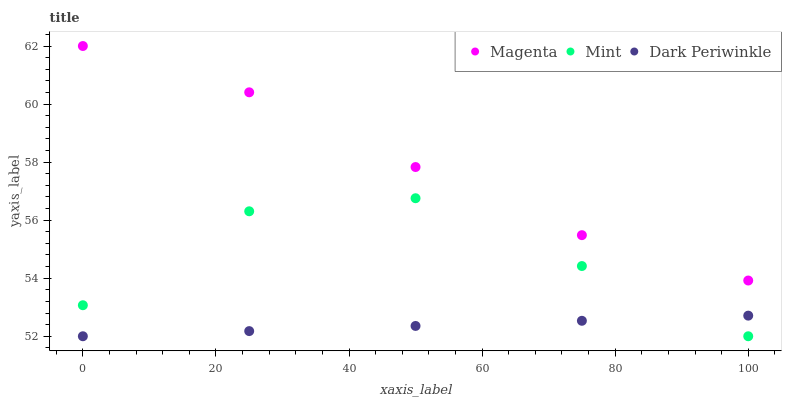Does Dark Periwinkle have the minimum area under the curve?
Answer yes or no. Yes. Does Magenta have the maximum area under the curve?
Answer yes or no. Yes. Does Mint have the minimum area under the curve?
Answer yes or no. No. Does Mint have the maximum area under the curve?
Answer yes or no. No. Is Dark Periwinkle the smoothest?
Answer yes or no. Yes. Is Mint the roughest?
Answer yes or no. Yes. Is Mint the smoothest?
Answer yes or no. No. Is Dark Periwinkle the roughest?
Answer yes or no. No. Does Mint have the lowest value?
Answer yes or no. Yes. Does Magenta have the highest value?
Answer yes or no. Yes. Does Mint have the highest value?
Answer yes or no. No. Is Dark Periwinkle less than Magenta?
Answer yes or no. Yes. Is Magenta greater than Dark Periwinkle?
Answer yes or no. Yes. Does Dark Periwinkle intersect Mint?
Answer yes or no. Yes. Is Dark Periwinkle less than Mint?
Answer yes or no. No. Is Dark Periwinkle greater than Mint?
Answer yes or no. No. Does Dark Periwinkle intersect Magenta?
Answer yes or no. No. 